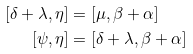<formula> <loc_0><loc_0><loc_500><loc_500>[ \delta + \lambda , \eta ] & = [ \mu , \beta + \alpha ] \\ [ \psi , \eta ] & = [ \delta + \lambda , \beta + \alpha ]</formula> 